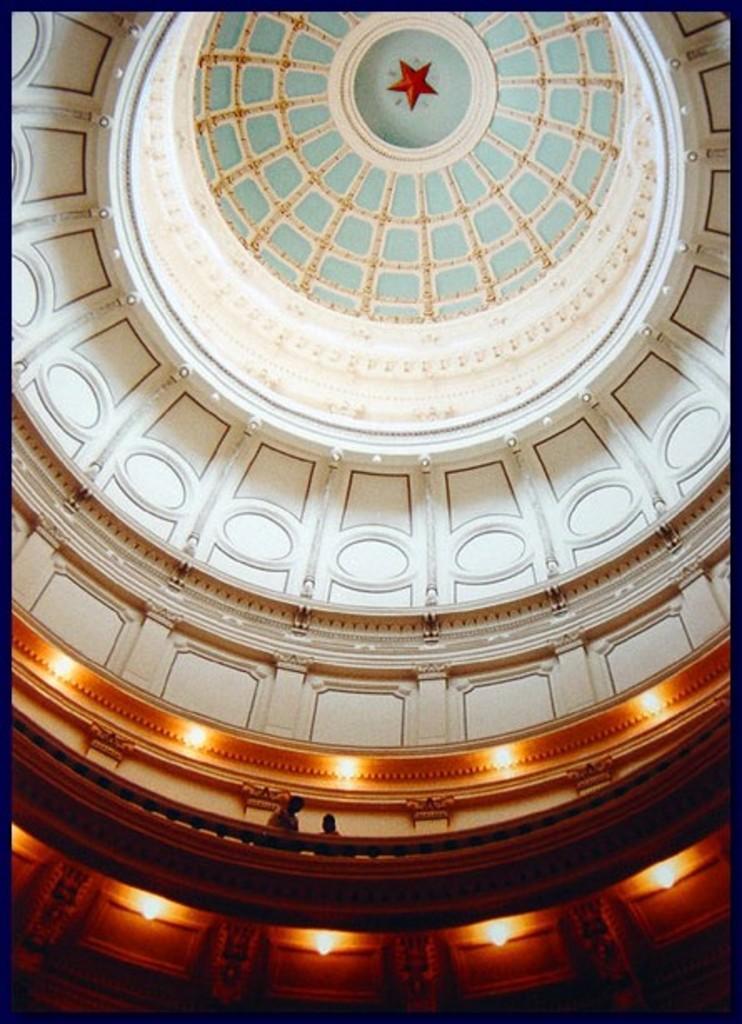Could you give a brief overview of what you see in this image? In the image there is a picture of a roof taken from inside a palace and there are two people standing on the floor above the stairs. 